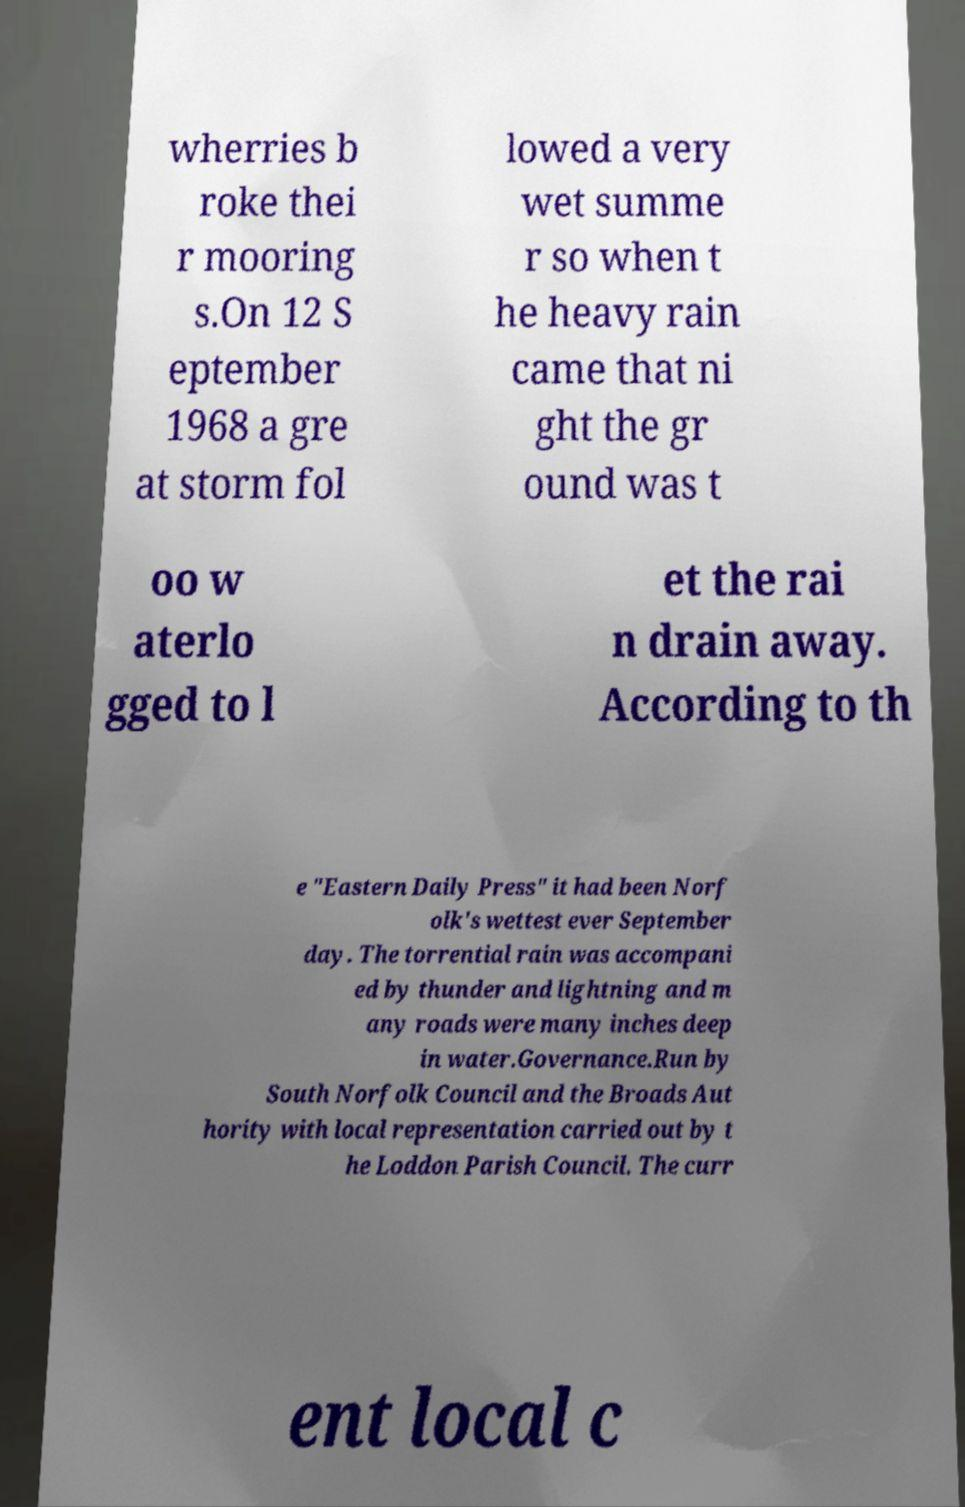Please read and relay the text visible in this image. What does it say? wherries b roke thei r mooring s.On 12 S eptember 1968 a gre at storm fol lowed a very wet summe r so when t he heavy rain came that ni ght the gr ound was t oo w aterlo gged to l et the rai n drain away. According to th e "Eastern Daily Press" it had been Norf olk's wettest ever September day. The torrential rain was accompani ed by thunder and lightning and m any roads were many inches deep in water.Governance.Run by South Norfolk Council and the Broads Aut hority with local representation carried out by t he Loddon Parish Council. The curr ent local c 